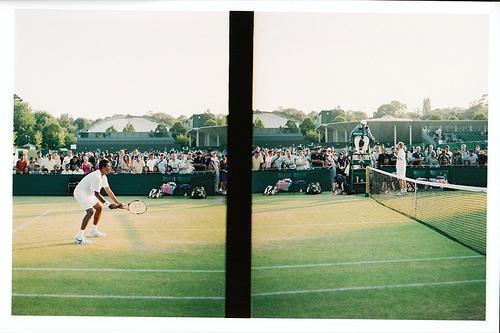How many people can be seen playing tennis?
Give a very brief answer. 1. 